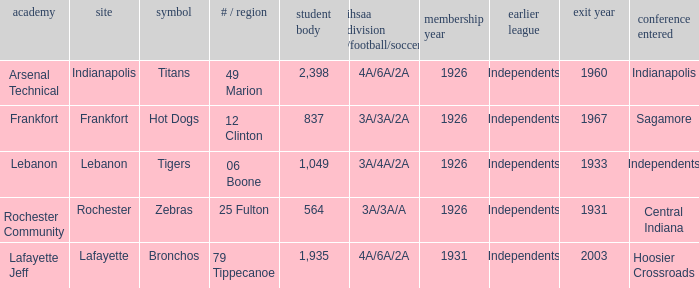What is the highest enrollment for rochester community school? 564.0. 